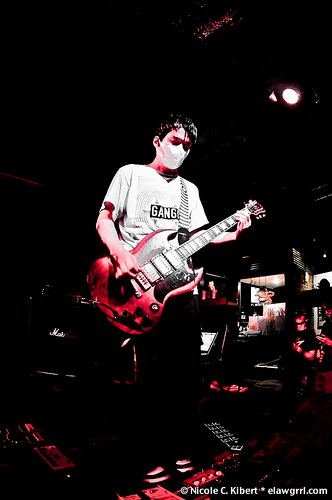<image>
Can you confirm if the guitar is next to the man? Yes. The guitar is positioned adjacent to the man, located nearby in the same general area. 